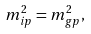Convert formula to latex. <formula><loc_0><loc_0><loc_500><loc_500>m _ { i p } ^ { 2 } = m _ { g p } ^ { 2 } ,</formula> 